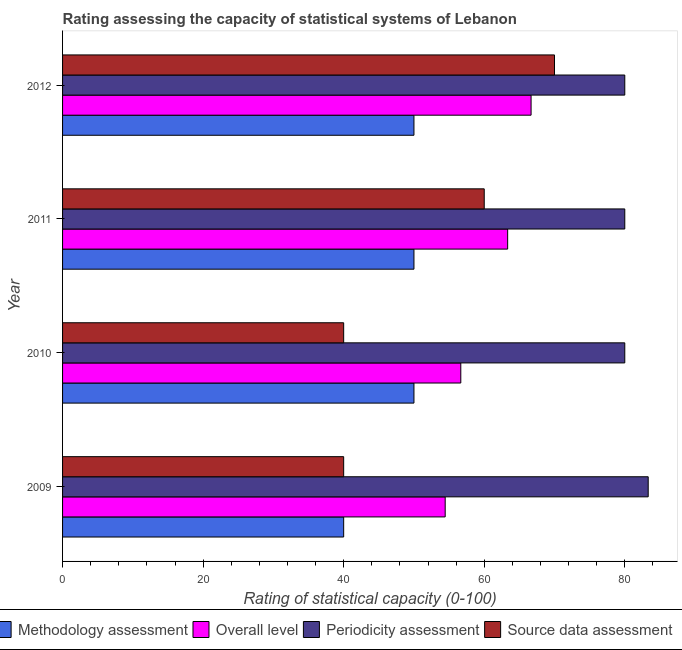How many different coloured bars are there?
Provide a short and direct response. 4. Are the number of bars per tick equal to the number of legend labels?
Make the answer very short. Yes. Are the number of bars on each tick of the Y-axis equal?
Keep it short and to the point. Yes. What is the label of the 2nd group of bars from the top?
Your response must be concise. 2011. In how many cases, is the number of bars for a given year not equal to the number of legend labels?
Provide a succinct answer. 0. What is the methodology assessment rating in 2009?
Make the answer very short. 40. Across all years, what is the maximum periodicity assessment rating?
Your answer should be very brief. 83.33. Across all years, what is the minimum methodology assessment rating?
Offer a terse response. 40. In which year was the periodicity assessment rating maximum?
Your answer should be very brief. 2009. In which year was the source data assessment rating minimum?
Offer a very short reply. 2009. What is the total source data assessment rating in the graph?
Your response must be concise. 210. What is the difference between the source data assessment rating in 2009 and that in 2012?
Keep it short and to the point. -30. What is the difference between the periodicity assessment rating in 2010 and the source data assessment rating in 2011?
Provide a succinct answer. 20. What is the average methodology assessment rating per year?
Make the answer very short. 47.5. In the year 2012, what is the difference between the overall level rating and periodicity assessment rating?
Make the answer very short. -13.33. What is the ratio of the overall level rating in 2009 to that in 2010?
Provide a succinct answer. 0.96. Is the difference between the source data assessment rating in 2009 and 2012 greater than the difference between the methodology assessment rating in 2009 and 2012?
Give a very brief answer. No. What is the difference between the highest and the lowest source data assessment rating?
Ensure brevity in your answer.  30. In how many years, is the overall level rating greater than the average overall level rating taken over all years?
Offer a very short reply. 2. Is the sum of the periodicity assessment rating in 2011 and 2012 greater than the maximum source data assessment rating across all years?
Your response must be concise. Yes. What does the 2nd bar from the top in 2010 represents?
Your answer should be compact. Periodicity assessment. What does the 4th bar from the bottom in 2011 represents?
Provide a succinct answer. Source data assessment. Is it the case that in every year, the sum of the methodology assessment rating and overall level rating is greater than the periodicity assessment rating?
Your response must be concise. Yes. How many years are there in the graph?
Ensure brevity in your answer.  4. What is the title of the graph?
Offer a very short reply. Rating assessing the capacity of statistical systems of Lebanon. What is the label or title of the X-axis?
Give a very brief answer. Rating of statistical capacity (0-100). What is the Rating of statistical capacity (0-100) of Methodology assessment in 2009?
Offer a very short reply. 40. What is the Rating of statistical capacity (0-100) in Overall level in 2009?
Make the answer very short. 54.44. What is the Rating of statistical capacity (0-100) in Periodicity assessment in 2009?
Your answer should be compact. 83.33. What is the Rating of statistical capacity (0-100) of Methodology assessment in 2010?
Your answer should be very brief. 50. What is the Rating of statistical capacity (0-100) in Overall level in 2010?
Make the answer very short. 56.67. What is the Rating of statistical capacity (0-100) in Periodicity assessment in 2010?
Provide a succinct answer. 80. What is the Rating of statistical capacity (0-100) of Methodology assessment in 2011?
Offer a terse response. 50. What is the Rating of statistical capacity (0-100) of Overall level in 2011?
Your answer should be very brief. 63.33. What is the Rating of statistical capacity (0-100) in Methodology assessment in 2012?
Ensure brevity in your answer.  50. What is the Rating of statistical capacity (0-100) in Overall level in 2012?
Provide a short and direct response. 66.67. Across all years, what is the maximum Rating of statistical capacity (0-100) of Overall level?
Offer a very short reply. 66.67. Across all years, what is the maximum Rating of statistical capacity (0-100) in Periodicity assessment?
Provide a succinct answer. 83.33. Across all years, what is the minimum Rating of statistical capacity (0-100) in Overall level?
Keep it short and to the point. 54.44. Across all years, what is the minimum Rating of statistical capacity (0-100) in Periodicity assessment?
Your answer should be compact. 80. What is the total Rating of statistical capacity (0-100) of Methodology assessment in the graph?
Keep it short and to the point. 190. What is the total Rating of statistical capacity (0-100) of Overall level in the graph?
Provide a succinct answer. 241.11. What is the total Rating of statistical capacity (0-100) in Periodicity assessment in the graph?
Give a very brief answer. 323.33. What is the total Rating of statistical capacity (0-100) of Source data assessment in the graph?
Your response must be concise. 210. What is the difference between the Rating of statistical capacity (0-100) in Methodology assessment in 2009 and that in 2010?
Provide a short and direct response. -10. What is the difference between the Rating of statistical capacity (0-100) in Overall level in 2009 and that in 2010?
Offer a very short reply. -2.22. What is the difference between the Rating of statistical capacity (0-100) in Source data assessment in 2009 and that in 2010?
Your answer should be compact. 0. What is the difference between the Rating of statistical capacity (0-100) in Methodology assessment in 2009 and that in 2011?
Ensure brevity in your answer.  -10. What is the difference between the Rating of statistical capacity (0-100) of Overall level in 2009 and that in 2011?
Keep it short and to the point. -8.89. What is the difference between the Rating of statistical capacity (0-100) of Source data assessment in 2009 and that in 2011?
Provide a short and direct response. -20. What is the difference between the Rating of statistical capacity (0-100) of Overall level in 2009 and that in 2012?
Your answer should be compact. -12.22. What is the difference between the Rating of statistical capacity (0-100) in Periodicity assessment in 2009 and that in 2012?
Provide a succinct answer. 3.33. What is the difference between the Rating of statistical capacity (0-100) in Methodology assessment in 2010 and that in 2011?
Your answer should be very brief. 0. What is the difference between the Rating of statistical capacity (0-100) of Overall level in 2010 and that in 2011?
Provide a short and direct response. -6.67. What is the difference between the Rating of statistical capacity (0-100) in Source data assessment in 2010 and that in 2011?
Make the answer very short. -20. What is the difference between the Rating of statistical capacity (0-100) in Methodology assessment in 2010 and that in 2012?
Provide a succinct answer. 0. What is the difference between the Rating of statistical capacity (0-100) in Overall level in 2010 and that in 2012?
Keep it short and to the point. -10. What is the difference between the Rating of statistical capacity (0-100) in Periodicity assessment in 2010 and that in 2012?
Your answer should be compact. 0. What is the difference between the Rating of statistical capacity (0-100) in Methodology assessment in 2011 and that in 2012?
Provide a short and direct response. 0. What is the difference between the Rating of statistical capacity (0-100) in Overall level in 2011 and that in 2012?
Ensure brevity in your answer.  -3.33. What is the difference between the Rating of statistical capacity (0-100) in Periodicity assessment in 2011 and that in 2012?
Provide a short and direct response. 0. What is the difference between the Rating of statistical capacity (0-100) of Methodology assessment in 2009 and the Rating of statistical capacity (0-100) of Overall level in 2010?
Keep it short and to the point. -16.67. What is the difference between the Rating of statistical capacity (0-100) of Methodology assessment in 2009 and the Rating of statistical capacity (0-100) of Periodicity assessment in 2010?
Provide a succinct answer. -40. What is the difference between the Rating of statistical capacity (0-100) in Overall level in 2009 and the Rating of statistical capacity (0-100) in Periodicity assessment in 2010?
Provide a succinct answer. -25.56. What is the difference between the Rating of statistical capacity (0-100) in Overall level in 2009 and the Rating of statistical capacity (0-100) in Source data assessment in 2010?
Your response must be concise. 14.44. What is the difference between the Rating of statistical capacity (0-100) in Periodicity assessment in 2009 and the Rating of statistical capacity (0-100) in Source data assessment in 2010?
Offer a very short reply. 43.33. What is the difference between the Rating of statistical capacity (0-100) in Methodology assessment in 2009 and the Rating of statistical capacity (0-100) in Overall level in 2011?
Provide a succinct answer. -23.33. What is the difference between the Rating of statistical capacity (0-100) in Overall level in 2009 and the Rating of statistical capacity (0-100) in Periodicity assessment in 2011?
Your answer should be compact. -25.56. What is the difference between the Rating of statistical capacity (0-100) of Overall level in 2009 and the Rating of statistical capacity (0-100) of Source data assessment in 2011?
Your response must be concise. -5.56. What is the difference between the Rating of statistical capacity (0-100) in Periodicity assessment in 2009 and the Rating of statistical capacity (0-100) in Source data assessment in 2011?
Give a very brief answer. 23.33. What is the difference between the Rating of statistical capacity (0-100) in Methodology assessment in 2009 and the Rating of statistical capacity (0-100) in Overall level in 2012?
Provide a short and direct response. -26.67. What is the difference between the Rating of statistical capacity (0-100) in Overall level in 2009 and the Rating of statistical capacity (0-100) in Periodicity assessment in 2012?
Provide a succinct answer. -25.56. What is the difference between the Rating of statistical capacity (0-100) of Overall level in 2009 and the Rating of statistical capacity (0-100) of Source data assessment in 2012?
Ensure brevity in your answer.  -15.56. What is the difference between the Rating of statistical capacity (0-100) in Periodicity assessment in 2009 and the Rating of statistical capacity (0-100) in Source data assessment in 2012?
Make the answer very short. 13.33. What is the difference between the Rating of statistical capacity (0-100) in Methodology assessment in 2010 and the Rating of statistical capacity (0-100) in Overall level in 2011?
Keep it short and to the point. -13.33. What is the difference between the Rating of statistical capacity (0-100) of Methodology assessment in 2010 and the Rating of statistical capacity (0-100) of Periodicity assessment in 2011?
Your response must be concise. -30. What is the difference between the Rating of statistical capacity (0-100) in Methodology assessment in 2010 and the Rating of statistical capacity (0-100) in Source data assessment in 2011?
Give a very brief answer. -10. What is the difference between the Rating of statistical capacity (0-100) of Overall level in 2010 and the Rating of statistical capacity (0-100) of Periodicity assessment in 2011?
Ensure brevity in your answer.  -23.33. What is the difference between the Rating of statistical capacity (0-100) in Overall level in 2010 and the Rating of statistical capacity (0-100) in Source data assessment in 2011?
Your answer should be very brief. -3.33. What is the difference between the Rating of statistical capacity (0-100) of Methodology assessment in 2010 and the Rating of statistical capacity (0-100) of Overall level in 2012?
Offer a terse response. -16.67. What is the difference between the Rating of statistical capacity (0-100) of Methodology assessment in 2010 and the Rating of statistical capacity (0-100) of Periodicity assessment in 2012?
Provide a short and direct response. -30. What is the difference between the Rating of statistical capacity (0-100) of Methodology assessment in 2010 and the Rating of statistical capacity (0-100) of Source data assessment in 2012?
Give a very brief answer. -20. What is the difference between the Rating of statistical capacity (0-100) of Overall level in 2010 and the Rating of statistical capacity (0-100) of Periodicity assessment in 2012?
Make the answer very short. -23.33. What is the difference between the Rating of statistical capacity (0-100) in Overall level in 2010 and the Rating of statistical capacity (0-100) in Source data assessment in 2012?
Your response must be concise. -13.33. What is the difference between the Rating of statistical capacity (0-100) of Periodicity assessment in 2010 and the Rating of statistical capacity (0-100) of Source data assessment in 2012?
Provide a short and direct response. 10. What is the difference between the Rating of statistical capacity (0-100) in Methodology assessment in 2011 and the Rating of statistical capacity (0-100) in Overall level in 2012?
Your answer should be compact. -16.67. What is the difference between the Rating of statistical capacity (0-100) of Methodology assessment in 2011 and the Rating of statistical capacity (0-100) of Source data assessment in 2012?
Offer a terse response. -20. What is the difference between the Rating of statistical capacity (0-100) in Overall level in 2011 and the Rating of statistical capacity (0-100) in Periodicity assessment in 2012?
Your answer should be very brief. -16.67. What is the difference between the Rating of statistical capacity (0-100) in Overall level in 2011 and the Rating of statistical capacity (0-100) in Source data assessment in 2012?
Offer a very short reply. -6.67. What is the average Rating of statistical capacity (0-100) of Methodology assessment per year?
Your answer should be very brief. 47.5. What is the average Rating of statistical capacity (0-100) of Overall level per year?
Offer a very short reply. 60.28. What is the average Rating of statistical capacity (0-100) of Periodicity assessment per year?
Your answer should be compact. 80.83. What is the average Rating of statistical capacity (0-100) of Source data assessment per year?
Ensure brevity in your answer.  52.5. In the year 2009, what is the difference between the Rating of statistical capacity (0-100) of Methodology assessment and Rating of statistical capacity (0-100) of Overall level?
Offer a very short reply. -14.44. In the year 2009, what is the difference between the Rating of statistical capacity (0-100) of Methodology assessment and Rating of statistical capacity (0-100) of Periodicity assessment?
Give a very brief answer. -43.33. In the year 2009, what is the difference between the Rating of statistical capacity (0-100) of Overall level and Rating of statistical capacity (0-100) of Periodicity assessment?
Make the answer very short. -28.89. In the year 2009, what is the difference between the Rating of statistical capacity (0-100) of Overall level and Rating of statistical capacity (0-100) of Source data assessment?
Offer a very short reply. 14.44. In the year 2009, what is the difference between the Rating of statistical capacity (0-100) in Periodicity assessment and Rating of statistical capacity (0-100) in Source data assessment?
Make the answer very short. 43.33. In the year 2010, what is the difference between the Rating of statistical capacity (0-100) in Methodology assessment and Rating of statistical capacity (0-100) in Overall level?
Your response must be concise. -6.67. In the year 2010, what is the difference between the Rating of statistical capacity (0-100) in Methodology assessment and Rating of statistical capacity (0-100) in Periodicity assessment?
Make the answer very short. -30. In the year 2010, what is the difference between the Rating of statistical capacity (0-100) in Overall level and Rating of statistical capacity (0-100) in Periodicity assessment?
Offer a very short reply. -23.33. In the year 2010, what is the difference between the Rating of statistical capacity (0-100) of Overall level and Rating of statistical capacity (0-100) of Source data assessment?
Give a very brief answer. 16.67. In the year 2011, what is the difference between the Rating of statistical capacity (0-100) in Methodology assessment and Rating of statistical capacity (0-100) in Overall level?
Provide a succinct answer. -13.33. In the year 2011, what is the difference between the Rating of statistical capacity (0-100) in Methodology assessment and Rating of statistical capacity (0-100) in Periodicity assessment?
Your answer should be compact. -30. In the year 2011, what is the difference between the Rating of statistical capacity (0-100) in Overall level and Rating of statistical capacity (0-100) in Periodicity assessment?
Give a very brief answer. -16.67. In the year 2012, what is the difference between the Rating of statistical capacity (0-100) of Methodology assessment and Rating of statistical capacity (0-100) of Overall level?
Offer a terse response. -16.67. In the year 2012, what is the difference between the Rating of statistical capacity (0-100) in Methodology assessment and Rating of statistical capacity (0-100) in Source data assessment?
Ensure brevity in your answer.  -20. In the year 2012, what is the difference between the Rating of statistical capacity (0-100) in Overall level and Rating of statistical capacity (0-100) in Periodicity assessment?
Your answer should be compact. -13.33. In the year 2012, what is the difference between the Rating of statistical capacity (0-100) of Overall level and Rating of statistical capacity (0-100) of Source data assessment?
Provide a succinct answer. -3.33. What is the ratio of the Rating of statistical capacity (0-100) of Methodology assessment in 2009 to that in 2010?
Provide a succinct answer. 0.8. What is the ratio of the Rating of statistical capacity (0-100) of Overall level in 2009 to that in 2010?
Keep it short and to the point. 0.96. What is the ratio of the Rating of statistical capacity (0-100) in Periodicity assessment in 2009 to that in 2010?
Provide a short and direct response. 1.04. What is the ratio of the Rating of statistical capacity (0-100) in Source data assessment in 2009 to that in 2010?
Your answer should be compact. 1. What is the ratio of the Rating of statistical capacity (0-100) of Overall level in 2009 to that in 2011?
Your response must be concise. 0.86. What is the ratio of the Rating of statistical capacity (0-100) in Periodicity assessment in 2009 to that in 2011?
Offer a terse response. 1.04. What is the ratio of the Rating of statistical capacity (0-100) in Source data assessment in 2009 to that in 2011?
Provide a succinct answer. 0.67. What is the ratio of the Rating of statistical capacity (0-100) in Methodology assessment in 2009 to that in 2012?
Ensure brevity in your answer.  0.8. What is the ratio of the Rating of statistical capacity (0-100) in Overall level in 2009 to that in 2012?
Give a very brief answer. 0.82. What is the ratio of the Rating of statistical capacity (0-100) of Periodicity assessment in 2009 to that in 2012?
Ensure brevity in your answer.  1.04. What is the ratio of the Rating of statistical capacity (0-100) in Source data assessment in 2009 to that in 2012?
Your answer should be very brief. 0.57. What is the ratio of the Rating of statistical capacity (0-100) in Methodology assessment in 2010 to that in 2011?
Your answer should be very brief. 1. What is the ratio of the Rating of statistical capacity (0-100) of Overall level in 2010 to that in 2011?
Keep it short and to the point. 0.89. What is the ratio of the Rating of statistical capacity (0-100) in Periodicity assessment in 2010 to that in 2011?
Keep it short and to the point. 1. What is the ratio of the Rating of statistical capacity (0-100) in Source data assessment in 2010 to that in 2011?
Give a very brief answer. 0.67. What is the ratio of the Rating of statistical capacity (0-100) in Overall level in 2010 to that in 2012?
Offer a terse response. 0.85. What is the ratio of the Rating of statistical capacity (0-100) in Periodicity assessment in 2010 to that in 2012?
Offer a terse response. 1. What is the ratio of the Rating of statistical capacity (0-100) of Methodology assessment in 2011 to that in 2012?
Ensure brevity in your answer.  1. What is the difference between the highest and the second highest Rating of statistical capacity (0-100) in Periodicity assessment?
Offer a very short reply. 3.33. What is the difference between the highest and the second highest Rating of statistical capacity (0-100) of Source data assessment?
Give a very brief answer. 10. What is the difference between the highest and the lowest Rating of statistical capacity (0-100) of Overall level?
Offer a very short reply. 12.22. What is the difference between the highest and the lowest Rating of statistical capacity (0-100) in Periodicity assessment?
Make the answer very short. 3.33. 